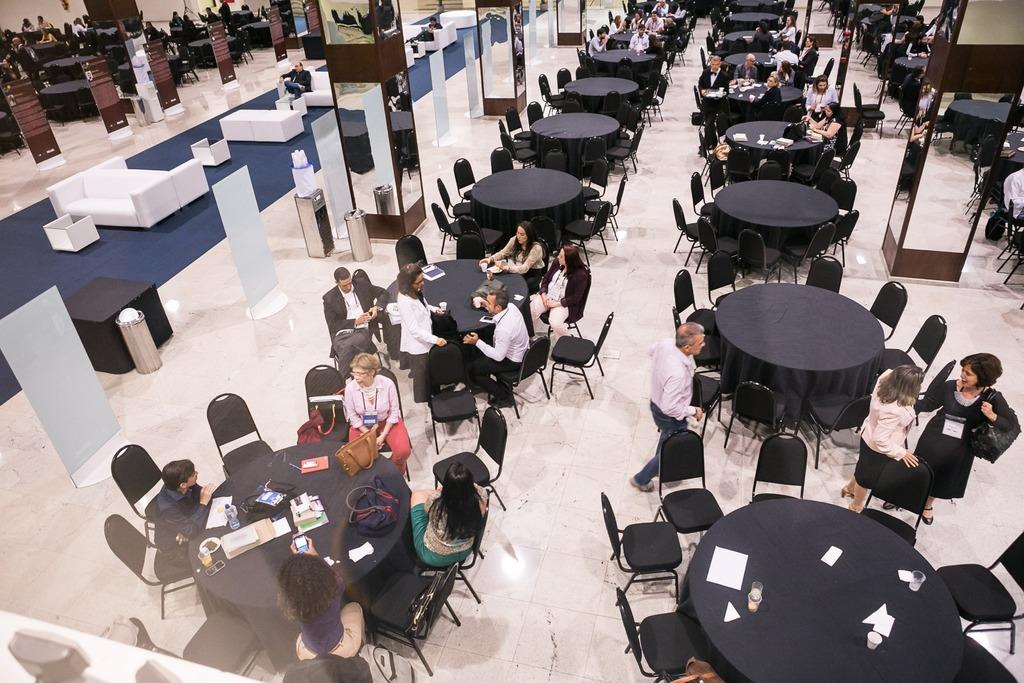How many types of furniture can be seen in the image? There are chairs, tables, and sofas in the image. What other objects are present in the image besides furniture? There are people, dustbins, and mirrors on pillars in the image. What might be used for disposing of waste in the image? Dustbins are present in the image for disposing of waste. What feature is present on the pillars in the image? There are mirrors on pillars in the image. What type of plants can be seen growing on the sofas in the image? There are no plants growing on the sofas in the image; only people, chairs, tables, sofas, dustbins, and mirrors on pillars are present. How does the channel affect the people in the image? There is no mention of a channel in the image, so it cannot affect the people in the image. 